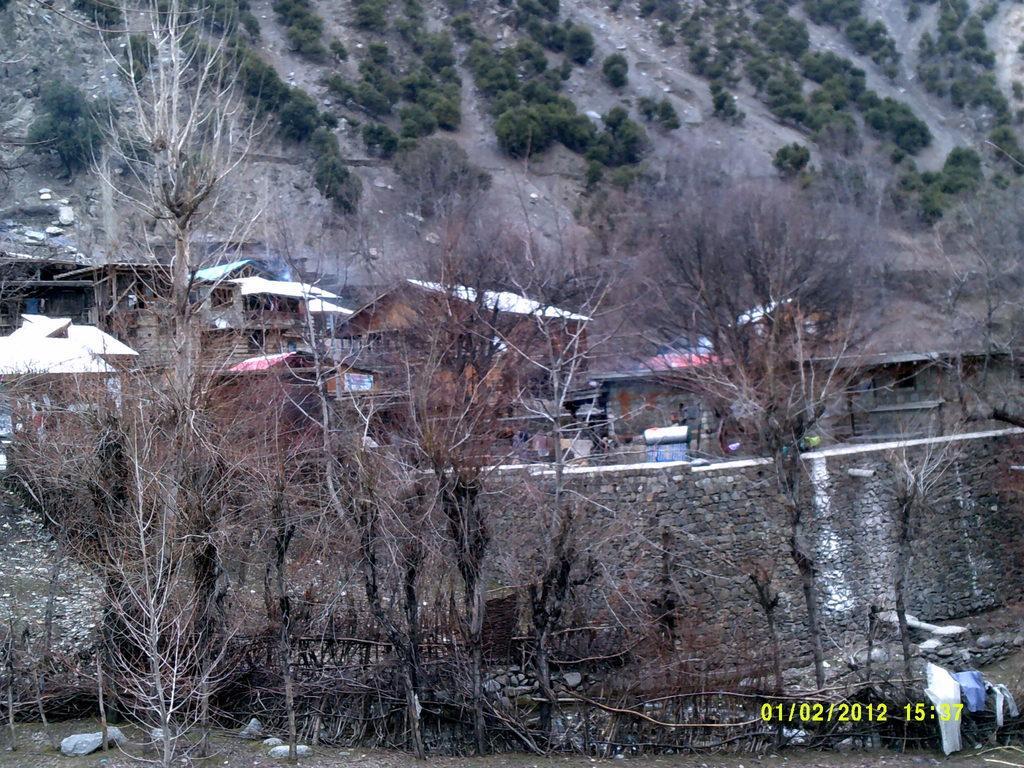Describe this image in one or two sentences. In this image I can see few trees,houses,stones,few clothes and dry trees. 